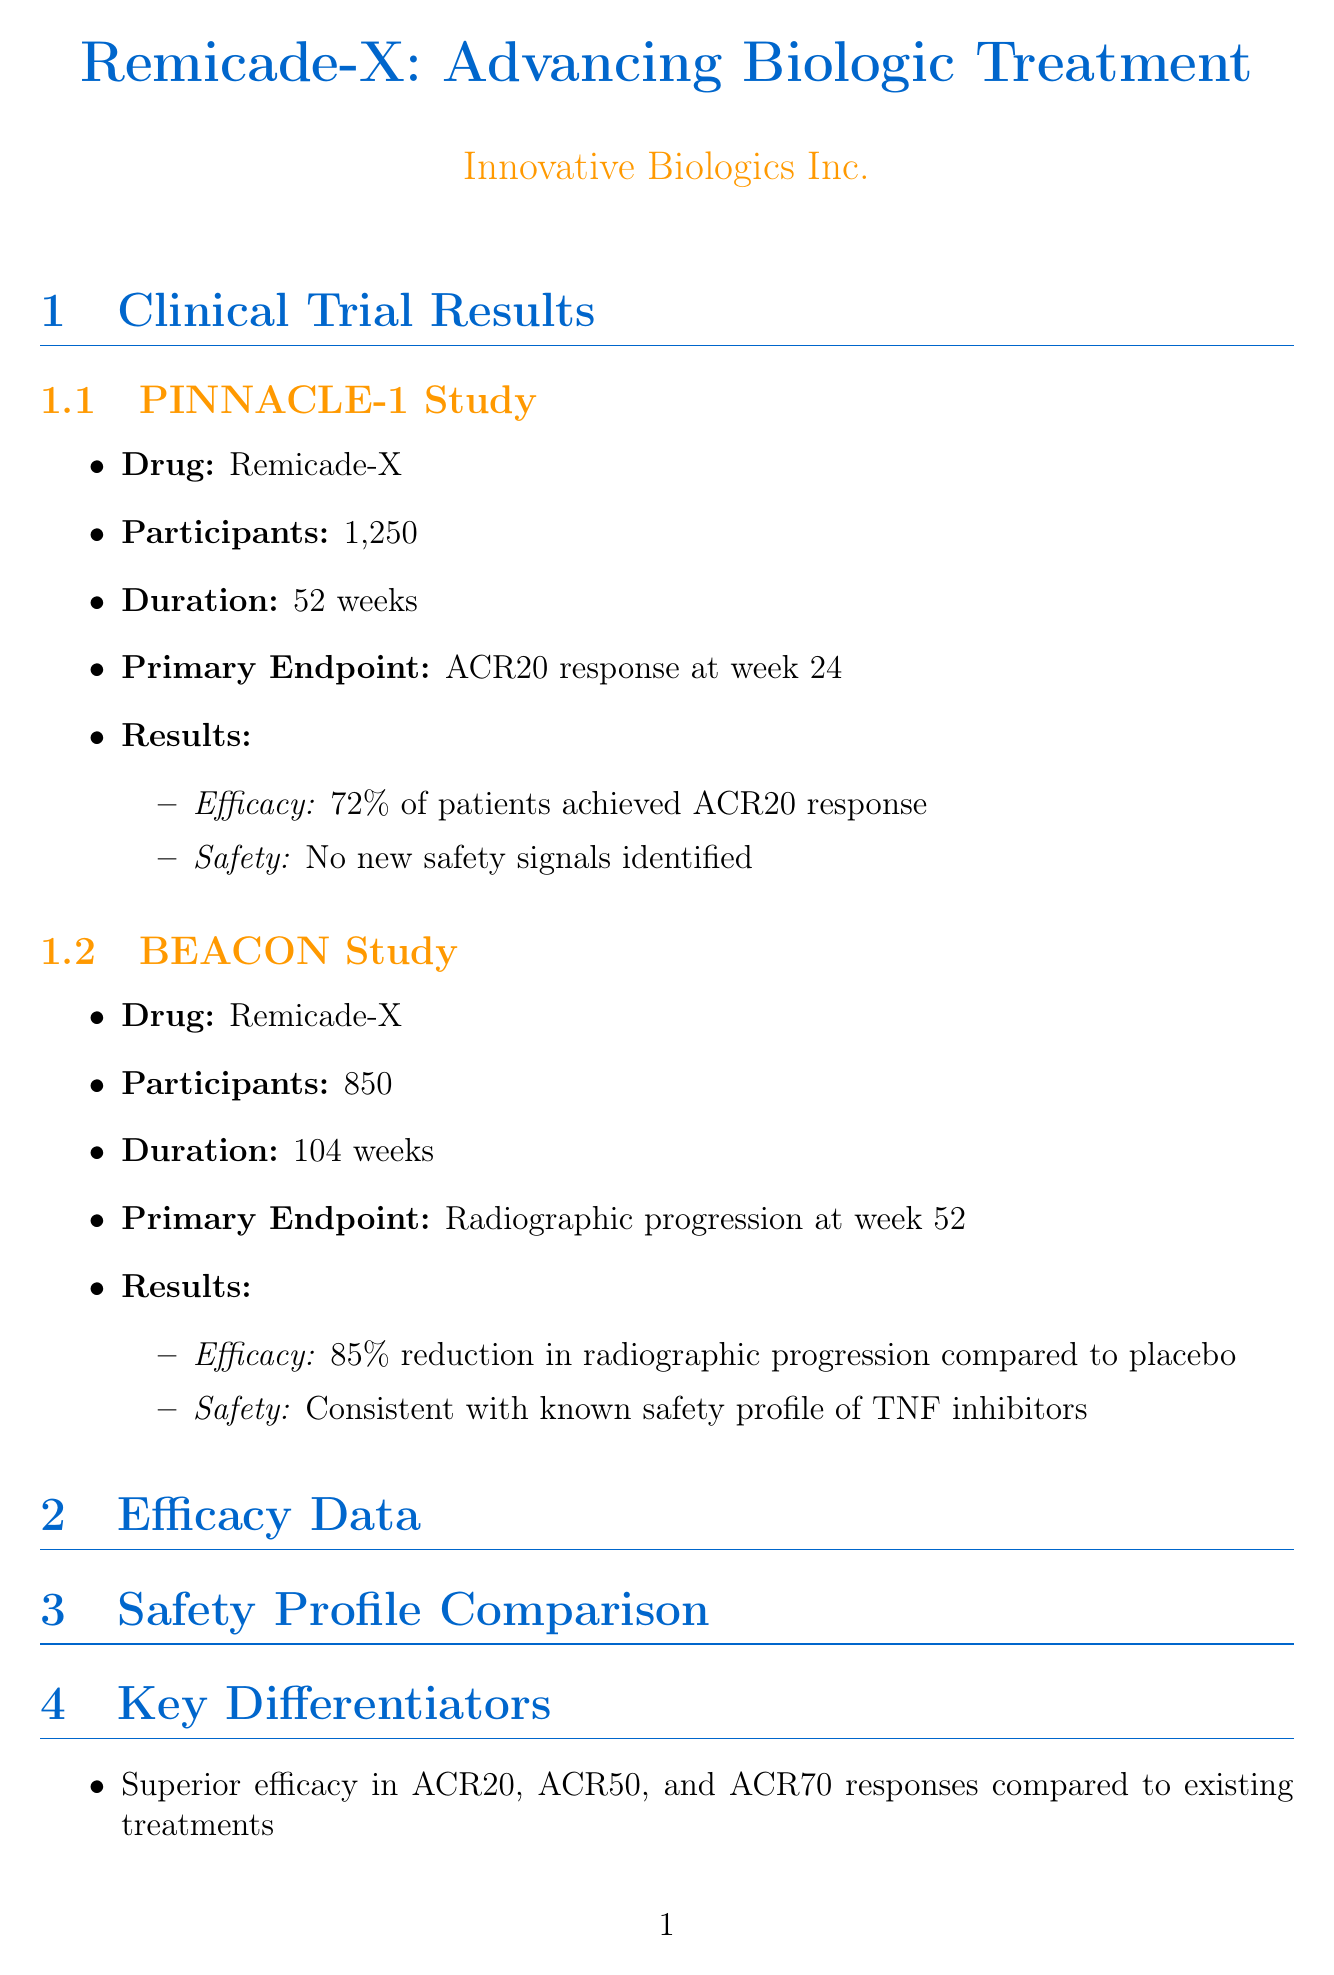What is the primary endpoint of the PINNACLE-1 study? The primary endpoint is stated in the document under the PINNACLE-1 study section, which is the ACR20 response at week 24.
Answer: ACR20 response at week 24 How many participants were in the BEACON study? The number of participants in the BEACON study is specified in the document as 850.
Answer: 850 What percentage of patients achieved ACR70 response with Remicade-X? The efficacy data section provides the response rates for ACR70, which shows that 43% of patients achieved this response with Remicade-X.
Answer: 43% What is the recommended dose of Remicade-X? The dosing and administration section specifies the recommended dose as 5 mg/kg intravenous infusion.
Answer: 5 mg/kg intravenous infusion What was the FDA approval date for Remicade-X? The market access information section includes the FDA approval date for Remicade-X, which is March 15, 2023.
Answer: March 15, 2023 Which adverse event has the lowest percentage for Remicade-X? The safety profile comparison table lists all adverse events and their corresponding rates; Nausea has the lowest percentage at 8%.
Answer: 8% How does the efficacy of Remicade-X compare to Humira in ACR50 response? The efficacy data shows that Remicade-X has a higher ACR50 response (58%) compared to Humira (52%), indicating superior efficacy.
Answer: Higher What is the ICER for Remicade-X per QALY gained? The cost-effectiveness data states that the ICER is $45,000 per QALY gained.
Answer: $45,000 per QALY gained What key differentiator is mentioned regarding the onset of action of Remicade-X? The document highlights that Remicade-X exhibits a rapid onset of action with significant improvements observed as early as week 2.
Answer: Rapid onset of action 